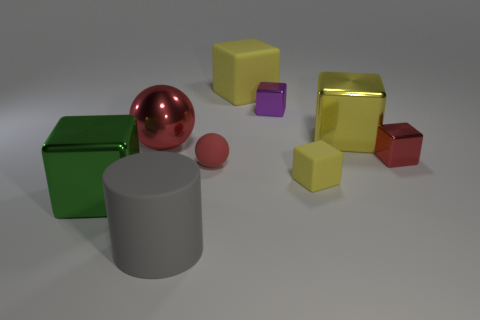What is the size of the red cube that is the same material as the small purple thing?
Give a very brief answer. Small. What number of large green things have the same shape as the tiny yellow thing?
Your answer should be very brief. 1. Does the purple cube have the same material as the small red object that is right of the matte ball?
Your answer should be very brief. Yes. Are there more matte things to the right of the red matte thing than gray objects?
Ensure brevity in your answer.  Yes. What is the shape of the large shiny object that is the same color as the tiny sphere?
Your response must be concise. Sphere. Is there a small red thing made of the same material as the big red sphere?
Ensure brevity in your answer.  Yes. Is the material of the yellow block that is in front of the tiny red metal cube the same as the red ball that is in front of the small red cube?
Your response must be concise. Yes. Are there the same number of blocks that are to the left of the small purple thing and tiny purple metallic cubes in front of the tiny red metallic cube?
Offer a terse response. No. What is the color of the cylinder that is the same size as the red shiny sphere?
Offer a terse response. Gray. Is there a cube that has the same color as the large sphere?
Your answer should be very brief. Yes. 